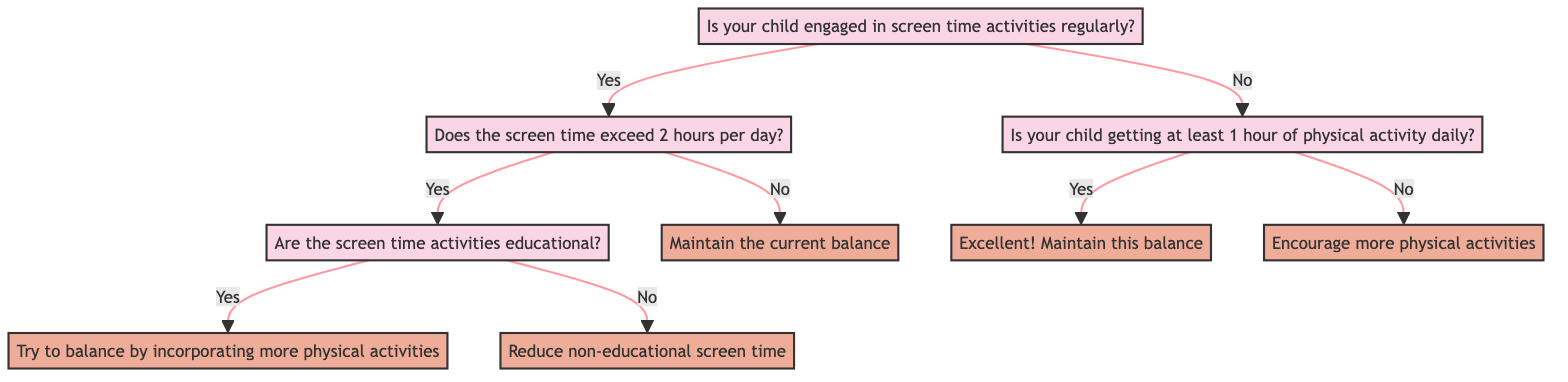Is your child engaged in screen time activities regularly? This is the root question of the decision tree. It determines whether the path will lead to questions about screen time habits or physical activity levels.
Answer: Yes or No What is the next question if the answer to the first question is yes? If the answer is yes, the next node in the decision tree is about whether the screen time exceeds 2 hours per day, which directly branches from the first question.
Answer: Does the screen time exceed 2 hours per day? If the screen time exceeds 2 hours per day and the activities are educational, what should be done? The decision tree indicates that if screen time exceeds 2 hours and the activities are educational, the advice is to balance this with more physical activities like outdoor play or sports.
Answer: Try to balance by incorporating more physical activities What decision should be made if the child is not engaged in screen time activities? If a child is not engaged in screen time, the next step is to check if they are getting at least 1 hour of physical activity daily, determining the following course of action based on their activity level.
Answer: Is your child getting at least 1 hour of physical activity daily? What action should a parent take if the child is getting less than one hour of physical activity daily? According to the decision tree, if the child is not getting at least one hour of physical activity daily, the recommendation is to encourage more physical activity through activities like family walks, dancing, or backyard games.
Answer: Encourage more physical activities What are the total number of decisions in this diagram? The diagram leads to four distinct decisions based on various paths taken through the questions, including balancing screen time with physical activities and recommendations based on physical activity levels.
Answer: Four decisions 